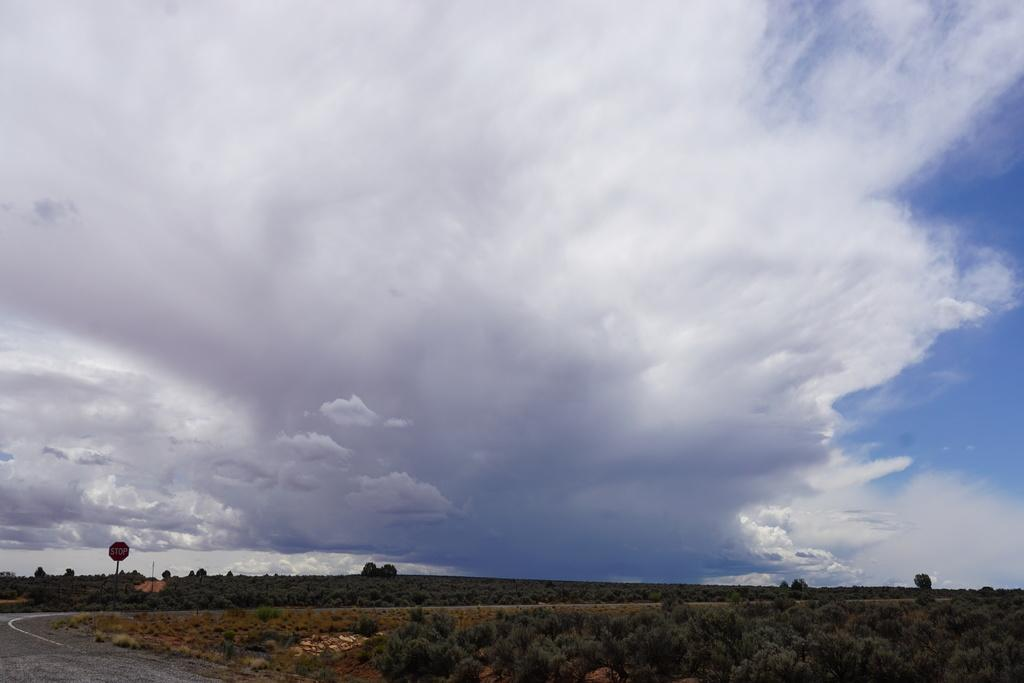What type of vegetation can be seen in the image? There are trees in the image. What is attached to the pole in the image? There is a sign board attached to the pole in the image. What can be seen on the ground in the image? There is a road in the image. What is visible in the background of the image? The sky is visible in the background of the image. What can be observed in the sky in the image? There are clouds in the sky. Where is the faucet located in the image? There is no faucet present in the image. What type of activity is taking place in the image involving snow? There is no snow or any activity involving snow in the image. 